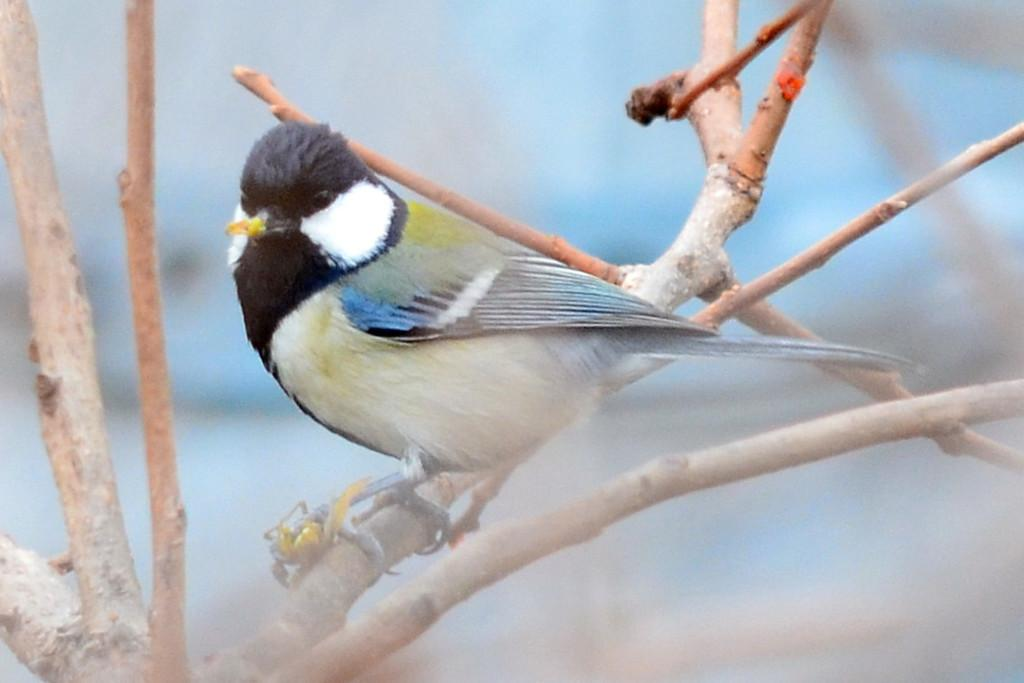What type of animal can be seen in the image? There is a bird in the image. What else is visible in the image besides the bird? There are stems visible in the image. Can you describe the background of the image? The background of the image is blurred. What type of badge is the bird wearing in the image? There is no badge present in the image; the bird is not wearing any accessories. 